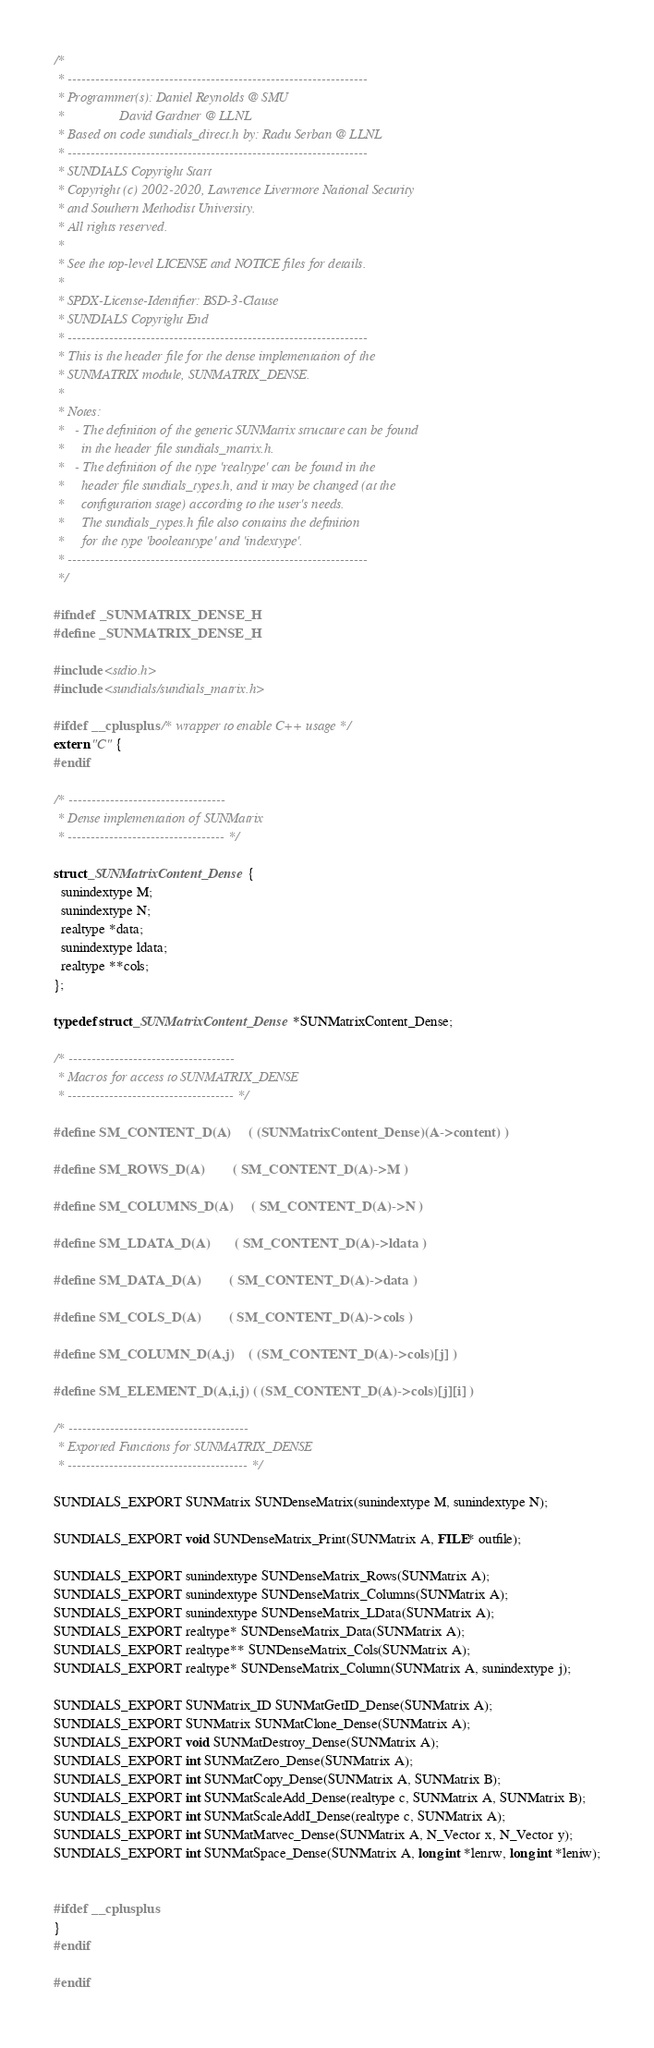<code> <loc_0><loc_0><loc_500><loc_500><_C_>/*
 * -----------------------------------------------------------------
 * Programmer(s): Daniel Reynolds @ SMU
 *                David Gardner @ LLNL
 * Based on code sundials_direct.h by: Radu Serban @ LLNL
 * -----------------------------------------------------------------
 * SUNDIALS Copyright Start
 * Copyright (c) 2002-2020, Lawrence Livermore National Security
 * and Southern Methodist University.
 * All rights reserved.
 *
 * See the top-level LICENSE and NOTICE files for details.
 *
 * SPDX-License-Identifier: BSD-3-Clause
 * SUNDIALS Copyright End
 * -----------------------------------------------------------------
 * This is the header file for the dense implementation of the 
 * SUNMATRIX module, SUNMATRIX_DENSE.
 *
 * Notes:
 *   - The definition of the generic SUNMatrix structure can be found
 *     in the header file sundials_matrix.h.
 *   - The definition of the type 'realtype' can be found in the
 *     header file sundials_types.h, and it may be changed (at the 
 *     configuration stage) according to the user's needs. 
 *     The sundials_types.h file also contains the definition
 *     for the type 'booleantype' and 'indextype'.
 * -----------------------------------------------------------------
 */

#ifndef _SUNMATRIX_DENSE_H
#define _SUNMATRIX_DENSE_H

#include <stdio.h>
#include <sundials/sundials_matrix.h>

#ifdef __cplusplus  /* wrapper to enable C++ usage */
extern "C" {
#endif

/* ----------------------------------
 * Dense implementation of SUNMatrix
 * ---------------------------------- */
  
struct _SUNMatrixContent_Dense {
  sunindextype M;
  sunindextype N;
  realtype *data;
  sunindextype ldata;
  realtype **cols;
};

typedef struct _SUNMatrixContent_Dense *SUNMatrixContent_Dense;

/* ------------------------------------
 * Macros for access to SUNMATRIX_DENSE
 * ------------------------------------ */

#define SM_CONTENT_D(A)     ( (SUNMatrixContent_Dense)(A->content) )

#define SM_ROWS_D(A)        ( SM_CONTENT_D(A)->M )

#define SM_COLUMNS_D(A)     ( SM_CONTENT_D(A)->N )

#define SM_LDATA_D(A)       ( SM_CONTENT_D(A)->ldata )

#define SM_DATA_D(A)        ( SM_CONTENT_D(A)->data )

#define SM_COLS_D(A)        ( SM_CONTENT_D(A)->cols )

#define SM_COLUMN_D(A,j)    ( (SM_CONTENT_D(A)->cols)[j] )

#define SM_ELEMENT_D(A,i,j) ( (SM_CONTENT_D(A)->cols)[j][i] )

/* ---------------------------------------
 * Exported Functions for SUNMATRIX_DENSE
 * --------------------------------------- */

SUNDIALS_EXPORT SUNMatrix SUNDenseMatrix(sunindextype M, sunindextype N);

SUNDIALS_EXPORT void SUNDenseMatrix_Print(SUNMatrix A, FILE* outfile);

SUNDIALS_EXPORT sunindextype SUNDenseMatrix_Rows(SUNMatrix A);
SUNDIALS_EXPORT sunindextype SUNDenseMatrix_Columns(SUNMatrix A);
SUNDIALS_EXPORT sunindextype SUNDenseMatrix_LData(SUNMatrix A);
SUNDIALS_EXPORT realtype* SUNDenseMatrix_Data(SUNMatrix A);
SUNDIALS_EXPORT realtype** SUNDenseMatrix_Cols(SUNMatrix A);
SUNDIALS_EXPORT realtype* SUNDenseMatrix_Column(SUNMatrix A, sunindextype j);

SUNDIALS_EXPORT SUNMatrix_ID SUNMatGetID_Dense(SUNMatrix A);
SUNDIALS_EXPORT SUNMatrix SUNMatClone_Dense(SUNMatrix A);
SUNDIALS_EXPORT void SUNMatDestroy_Dense(SUNMatrix A);
SUNDIALS_EXPORT int SUNMatZero_Dense(SUNMatrix A);
SUNDIALS_EXPORT int SUNMatCopy_Dense(SUNMatrix A, SUNMatrix B);
SUNDIALS_EXPORT int SUNMatScaleAdd_Dense(realtype c, SUNMatrix A, SUNMatrix B);
SUNDIALS_EXPORT int SUNMatScaleAddI_Dense(realtype c, SUNMatrix A);
SUNDIALS_EXPORT int SUNMatMatvec_Dense(SUNMatrix A, N_Vector x, N_Vector y);
SUNDIALS_EXPORT int SUNMatSpace_Dense(SUNMatrix A, long int *lenrw, long int *leniw);

  
#ifdef __cplusplus
}
#endif

#endif
</code> 